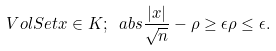Convert formula to latex. <formula><loc_0><loc_0><loc_500><loc_500>\ V o l S e t { x \in K ; \ a b s { \frac { | x | } { \sqrt { n } } - \rho } \geq \epsilon \rho } \leq \epsilon .</formula> 